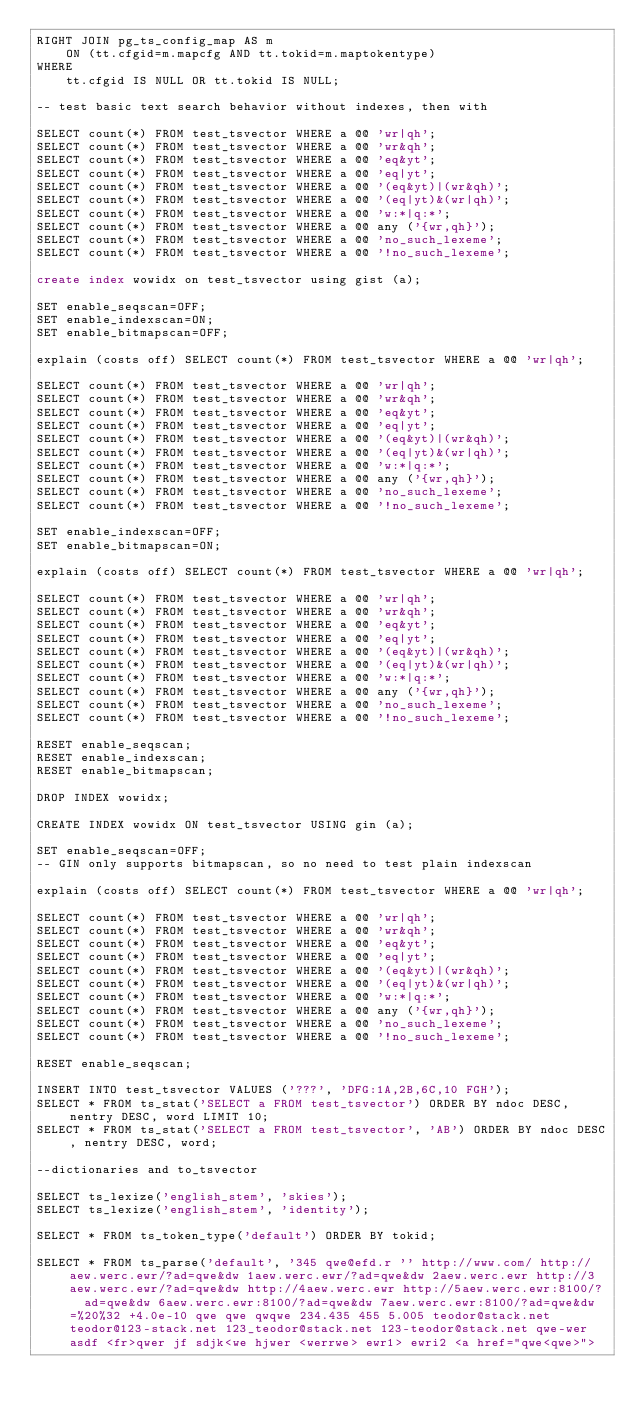<code> <loc_0><loc_0><loc_500><loc_500><_SQL_>RIGHT JOIN pg_ts_config_map AS m
    ON (tt.cfgid=m.mapcfg AND tt.tokid=m.maptokentype)
WHERE
    tt.cfgid IS NULL OR tt.tokid IS NULL;

-- test basic text search behavior without indexes, then with

SELECT count(*) FROM test_tsvector WHERE a @@ 'wr|qh';
SELECT count(*) FROM test_tsvector WHERE a @@ 'wr&qh';
SELECT count(*) FROM test_tsvector WHERE a @@ 'eq&yt';
SELECT count(*) FROM test_tsvector WHERE a @@ 'eq|yt';
SELECT count(*) FROM test_tsvector WHERE a @@ '(eq&yt)|(wr&qh)';
SELECT count(*) FROM test_tsvector WHERE a @@ '(eq|yt)&(wr|qh)';
SELECT count(*) FROM test_tsvector WHERE a @@ 'w:*|q:*';
SELECT count(*) FROM test_tsvector WHERE a @@ any ('{wr,qh}');
SELECT count(*) FROM test_tsvector WHERE a @@ 'no_such_lexeme';
SELECT count(*) FROM test_tsvector WHERE a @@ '!no_such_lexeme';

create index wowidx on test_tsvector using gist (a);

SET enable_seqscan=OFF;
SET enable_indexscan=ON;
SET enable_bitmapscan=OFF;

explain (costs off) SELECT count(*) FROM test_tsvector WHERE a @@ 'wr|qh';

SELECT count(*) FROM test_tsvector WHERE a @@ 'wr|qh';
SELECT count(*) FROM test_tsvector WHERE a @@ 'wr&qh';
SELECT count(*) FROM test_tsvector WHERE a @@ 'eq&yt';
SELECT count(*) FROM test_tsvector WHERE a @@ 'eq|yt';
SELECT count(*) FROM test_tsvector WHERE a @@ '(eq&yt)|(wr&qh)';
SELECT count(*) FROM test_tsvector WHERE a @@ '(eq|yt)&(wr|qh)';
SELECT count(*) FROM test_tsvector WHERE a @@ 'w:*|q:*';
SELECT count(*) FROM test_tsvector WHERE a @@ any ('{wr,qh}');
SELECT count(*) FROM test_tsvector WHERE a @@ 'no_such_lexeme';
SELECT count(*) FROM test_tsvector WHERE a @@ '!no_such_lexeme';

SET enable_indexscan=OFF;
SET enable_bitmapscan=ON;

explain (costs off) SELECT count(*) FROM test_tsvector WHERE a @@ 'wr|qh';

SELECT count(*) FROM test_tsvector WHERE a @@ 'wr|qh';
SELECT count(*) FROM test_tsvector WHERE a @@ 'wr&qh';
SELECT count(*) FROM test_tsvector WHERE a @@ 'eq&yt';
SELECT count(*) FROM test_tsvector WHERE a @@ 'eq|yt';
SELECT count(*) FROM test_tsvector WHERE a @@ '(eq&yt)|(wr&qh)';
SELECT count(*) FROM test_tsvector WHERE a @@ '(eq|yt)&(wr|qh)';
SELECT count(*) FROM test_tsvector WHERE a @@ 'w:*|q:*';
SELECT count(*) FROM test_tsvector WHERE a @@ any ('{wr,qh}');
SELECT count(*) FROM test_tsvector WHERE a @@ 'no_such_lexeme';
SELECT count(*) FROM test_tsvector WHERE a @@ '!no_such_lexeme';

RESET enable_seqscan;
RESET enable_indexscan;
RESET enable_bitmapscan;

DROP INDEX wowidx;

CREATE INDEX wowidx ON test_tsvector USING gin (a);

SET enable_seqscan=OFF;
-- GIN only supports bitmapscan, so no need to test plain indexscan

explain (costs off) SELECT count(*) FROM test_tsvector WHERE a @@ 'wr|qh';

SELECT count(*) FROM test_tsvector WHERE a @@ 'wr|qh';
SELECT count(*) FROM test_tsvector WHERE a @@ 'wr&qh';
SELECT count(*) FROM test_tsvector WHERE a @@ 'eq&yt';
SELECT count(*) FROM test_tsvector WHERE a @@ 'eq|yt';
SELECT count(*) FROM test_tsvector WHERE a @@ '(eq&yt)|(wr&qh)';
SELECT count(*) FROM test_tsvector WHERE a @@ '(eq|yt)&(wr|qh)';
SELECT count(*) FROM test_tsvector WHERE a @@ 'w:*|q:*';
SELECT count(*) FROM test_tsvector WHERE a @@ any ('{wr,qh}');
SELECT count(*) FROM test_tsvector WHERE a @@ 'no_such_lexeme';
SELECT count(*) FROM test_tsvector WHERE a @@ '!no_such_lexeme';

RESET enable_seqscan;

INSERT INTO test_tsvector VALUES ('???', 'DFG:1A,2B,6C,10 FGH');
SELECT * FROM ts_stat('SELECT a FROM test_tsvector') ORDER BY ndoc DESC, nentry DESC, word LIMIT 10;
SELECT * FROM ts_stat('SELECT a FROM test_tsvector', 'AB') ORDER BY ndoc DESC, nentry DESC, word;

--dictionaries and to_tsvector

SELECT ts_lexize('english_stem', 'skies');
SELECT ts_lexize('english_stem', 'identity');

SELECT * FROM ts_token_type('default') ORDER BY tokid;

SELECT * FROM ts_parse('default', '345 qwe@efd.r '' http://www.com/ http://aew.werc.ewr/?ad=qwe&dw 1aew.werc.ewr/?ad=qwe&dw 2aew.werc.ewr http://3aew.werc.ewr/?ad=qwe&dw http://4aew.werc.ewr http://5aew.werc.ewr:8100/?  ad=qwe&dw 6aew.werc.ewr:8100/?ad=qwe&dw 7aew.werc.ewr:8100/?ad=qwe&dw=%20%32 +4.0e-10 qwe qwe qwqwe 234.435 455 5.005 teodor@stack.net teodor@123-stack.net 123_teodor@stack.net 123-teodor@stack.net qwe-wer asdf <fr>qwer jf sdjk<we hjwer <werrwe> ewr1> ewri2 <a href="qwe<qwe>"></code> 